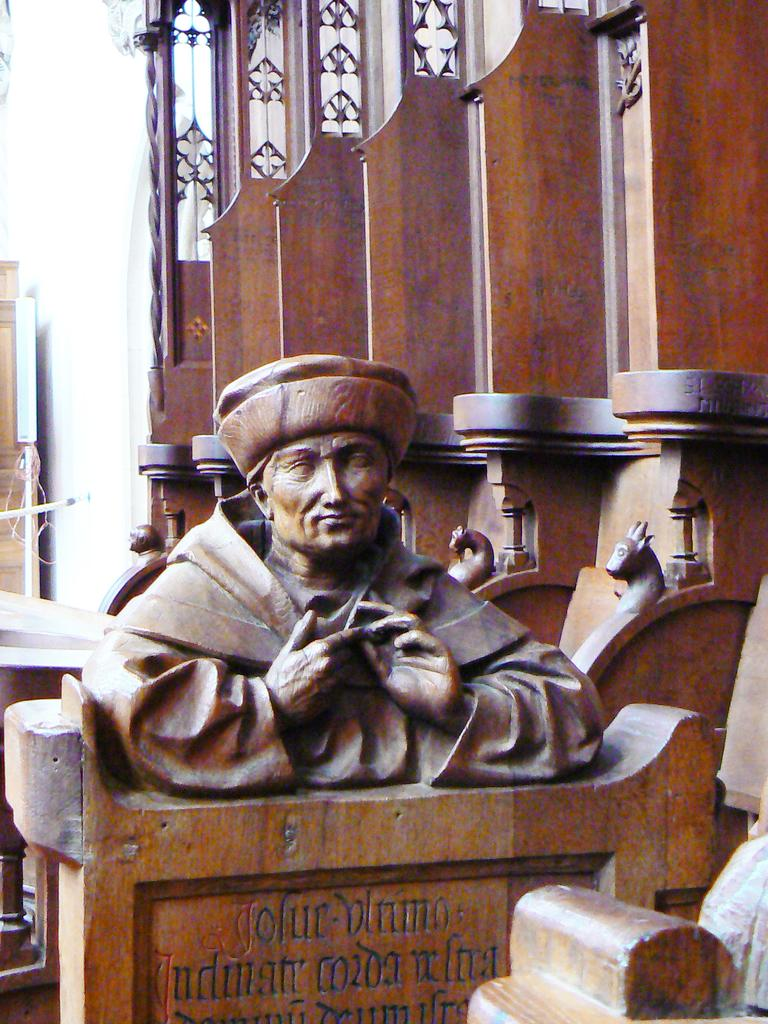What is the main subject of the image? There is a statue in the image. Can you describe the colors of the statue? The statue has brown and black colors. What type of material is visible in the image? There are wooden objects visible in the image. What type of advertisement can be seen on the statue in the image? There is no advertisement present on the statue in the image. Where might this statue be located, considering the presence of wooden objects? The presence of wooden objects does not necessarily indicate the location of the statue. It could be in a park, but the facts provided do not specify the location. 